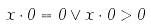<formula> <loc_0><loc_0><loc_500><loc_500>x \cdot 0 = 0 \lor x \cdot 0 > 0</formula> 